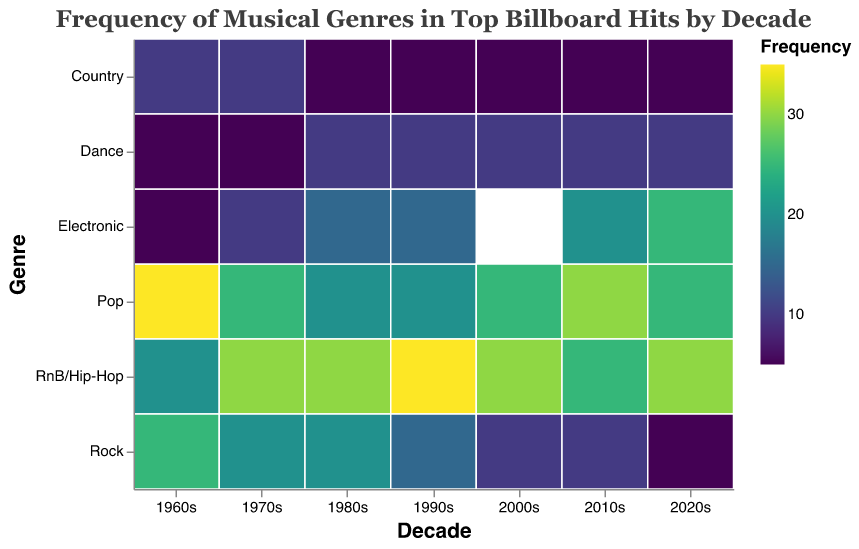What's the most frequent genre in the 1960s? Look at the heatmap cell colors in the 1960s column. The darkest color represents the highest frequency. Pop has the darkest color, indicating 35.
Answer: Pop In which decade does Rock have the lowest frequency? Check the heatmap cells in the Rock row for the decade with the lightest color (lowest frequency). The 2020s have the lightest color, representing 5.
Answer: 2020s How does the frequency of Electronic change from the 1980s to the 2020s? Compare the values in the Electronic row for these two decades: 1980s (15) and 2020s (25).
Answer: Increases Which decade shows the most balanced genre frequencies? Identify the decade where the heatmap colors in its column are the most balanced, i.e., no single genre dominates. The 1970s show this balance.
Answer: 1970s What is the sum of the frequencies of Pop and RnB/Hip-Hop in the 1990s? Add the values for Pop and RnB/Hip-Hop in the 1990s column: 20 (Pop) + 35 (RnB/Hip-Hop) = 55.
Answer: 55 What's the average frequency of Dance in the decades shown? Calculate the average of Dance frequencies: (5+5+10+10+10+10+10)/7 = 60/7 ≈ 8.57.
Answer: ≈ 8.57 Which genre had a higher increase in frequency from the 2000s to 2010s, Pop or Electronic? Compare the increases: Pop: 30 (2010s) - 25 (2000s) = 5 and Electronic: 20 (2010s) - 20 (2000s) = 0.
Answer: Pop In which decade did RnB/Hip-Hop become the most frequent genre? Find the first decade where RnB/Hip-Hop has the darkest color in the column. It starts in the 1970s.
Answer: 1970s How does the frequency of Country change throughout the decades? Observe the colors for Country row from the 1960s to the 2020s: 10, 10, 5, 5, 5, 5, 5 – mostly constant except a drop after the 1970s.
Answer: Mostly constant, slight drop after 1970s 